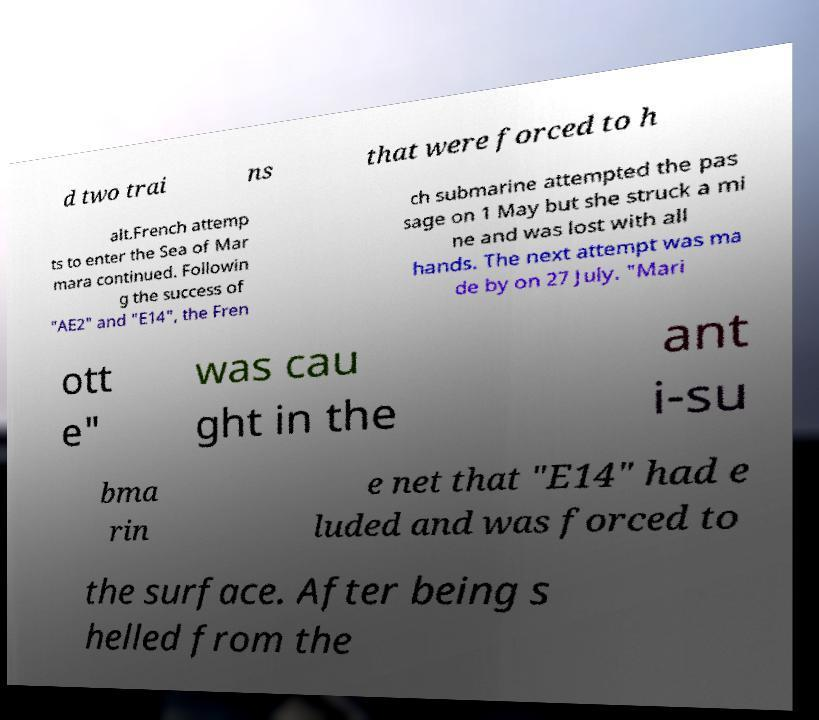Please read and relay the text visible in this image. What does it say? d two trai ns that were forced to h alt.French attemp ts to enter the Sea of Mar mara continued. Followin g the success of "AE2" and "E14", the Fren ch submarine attempted the pas sage on 1 May but she struck a mi ne and was lost with all hands. The next attempt was ma de by on 27 July. "Mari ott e" was cau ght in the ant i-su bma rin e net that "E14" had e luded and was forced to the surface. After being s helled from the 